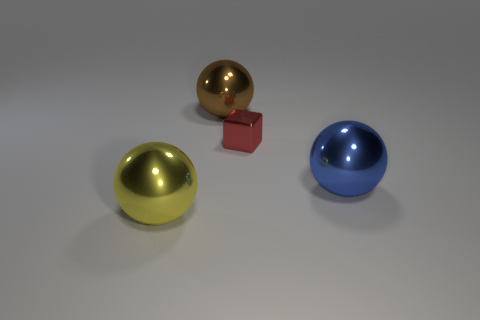Add 2 big metal objects. How many objects exist? 6 Subtract all spheres. How many objects are left? 1 Add 3 large blue objects. How many large blue objects are left? 4 Add 4 gray cylinders. How many gray cylinders exist? 4 Subtract 0 green blocks. How many objects are left? 4 Subtract all blue spheres. Subtract all large blue objects. How many objects are left? 2 